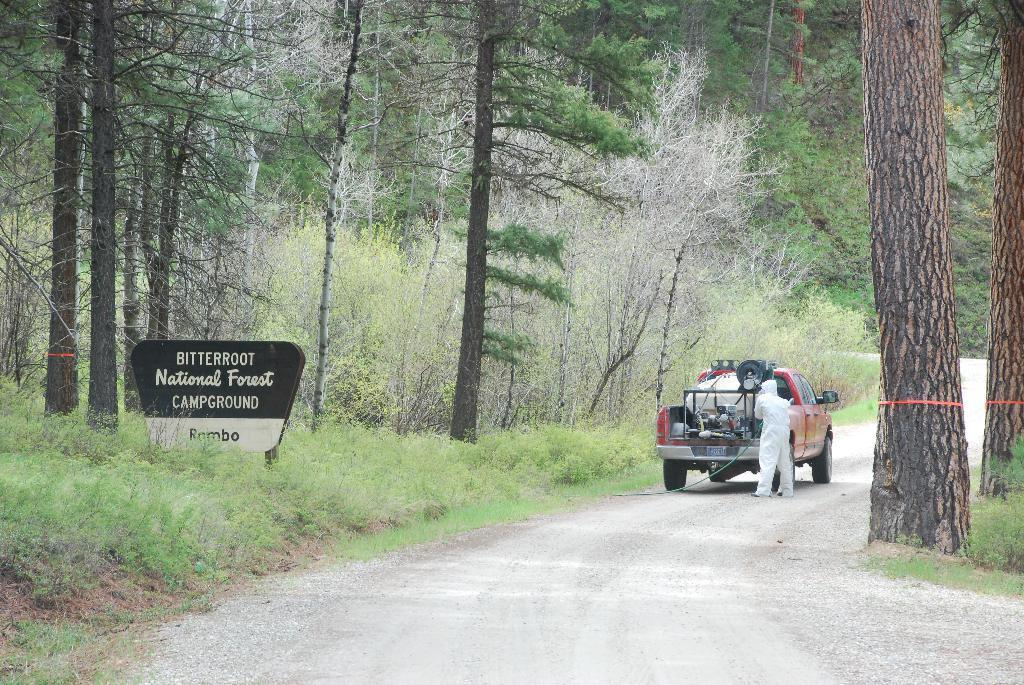Describe this image in one or two sentences. In this image I can see a vehicle and I can also see a person standing and the person is wearing white color dress. Background I can see a board in white and black color and trees in green color. 